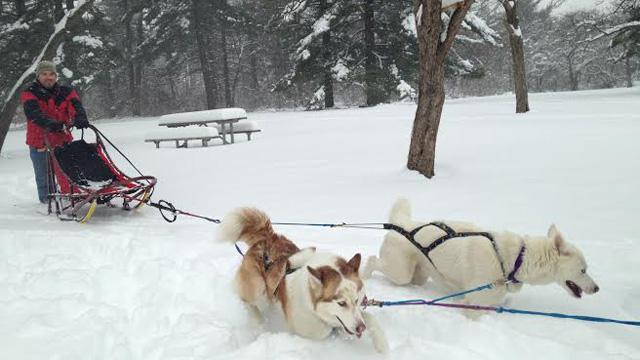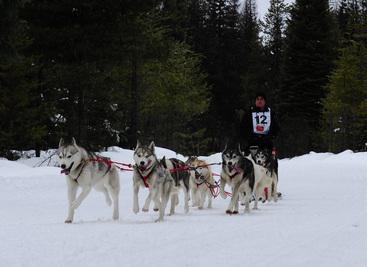The first image is the image on the left, the second image is the image on the right. For the images shown, is this caption "An image shows a sled driver standing behind an empty sled, and only two visible dogs pulling it." true? Answer yes or no. Yes. The first image is the image on the left, the second image is the image on the right. Assess this claim about the two images: "All the sleds are pointing to the left.". Correct or not? Answer yes or no. No. 